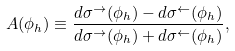Convert formula to latex. <formula><loc_0><loc_0><loc_500><loc_500>A ( \phi _ { h } ) \equiv \frac { d \sigma ^ { \to } ( \phi _ { h } ) - d \sigma ^ { \gets } ( \phi _ { h } ) } { d \sigma ^ { \to } ( \phi _ { h } ) + d \sigma ^ { \gets } ( \phi _ { h } ) } ,</formula> 